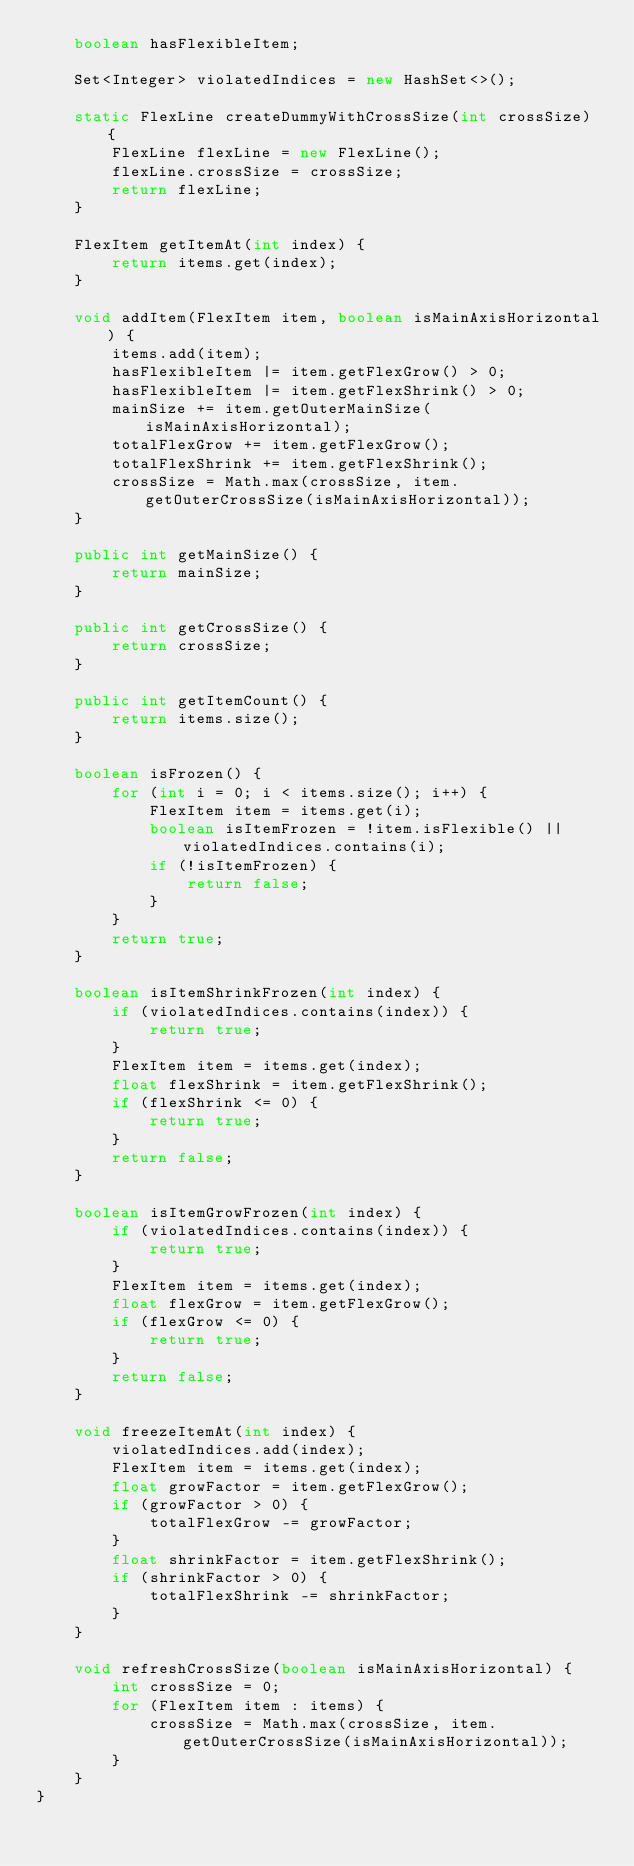<code> <loc_0><loc_0><loc_500><loc_500><_Java_>    boolean hasFlexibleItem;

    Set<Integer> violatedIndices = new HashSet<>();

    static FlexLine createDummyWithCrossSize(int crossSize) {
        FlexLine flexLine = new FlexLine();
        flexLine.crossSize = crossSize;
        return flexLine;
    }

    FlexItem getItemAt(int index) {
        return items.get(index);
    }

    void addItem(FlexItem item, boolean isMainAxisHorizontal) {
        items.add(item);
        hasFlexibleItem |= item.getFlexGrow() > 0;
        hasFlexibleItem |= item.getFlexShrink() > 0;
        mainSize += item.getOuterMainSize(isMainAxisHorizontal);
        totalFlexGrow += item.getFlexGrow();
        totalFlexShrink += item.getFlexShrink();
        crossSize = Math.max(crossSize, item.getOuterCrossSize(isMainAxisHorizontal));
    }

    public int getMainSize() {
        return mainSize;
    }

    public int getCrossSize() {
        return crossSize;
    }

    public int getItemCount() {
        return items.size();
    }

    boolean isFrozen() {
        for (int i = 0; i < items.size(); i++) {
            FlexItem item = items.get(i);
            boolean isItemFrozen = !item.isFlexible() || violatedIndices.contains(i);
            if (!isItemFrozen) {
                return false;
            }
        }
        return true;
    }

    boolean isItemShrinkFrozen(int index) {
        if (violatedIndices.contains(index)) {
            return true;
        }
        FlexItem item = items.get(index);
        float flexShrink = item.getFlexShrink();
        if (flexShrink <= 0) {
            return true;
        }
        return false;
    }

    boolean isItemGrowFrozen(int index) {
        if (violatedIndices.contains(index)) {
            return true;
        }
        FlexItem item = items.get(index);
        float flexGrow = item.getFlexGrow();
        if (flexGrow <= 0) {
            return true;
        }
        return false;
    }

    void freezeItemAt(int index) {
        violatedIndices.add(index);
        FlexItem item = items.get(index);
        float growFactor = item.getFlexGrow();
        if (growFactor > 0) {
            totalFlexGrow -= growFactor;
        }
        float shrinkFactor = item.getFlexShrink();
        if (shrinkFactor > 0) {
            totalFlexShrink -= shrinkFactor;
        }
    }

    void refreshCrossSize(boolean isMainAxisHorizontal) {
        int crossSize = 0;
        for (FlexItem item : items) {
            crossSize = Math.max(crossSize, item.getOuterCrossSize(isMainAxisHorizontal));
        }
    }
}
</code> 